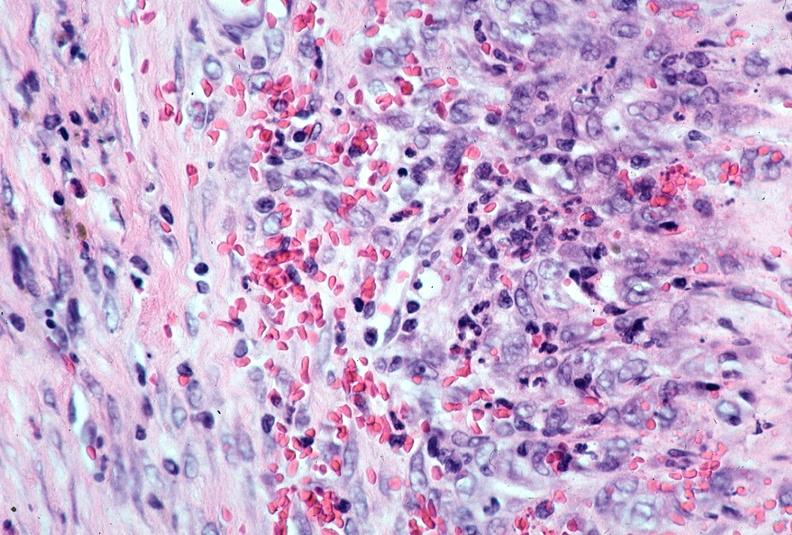what is present?
Answer the question using a single word or phrase. Cardiovascular 